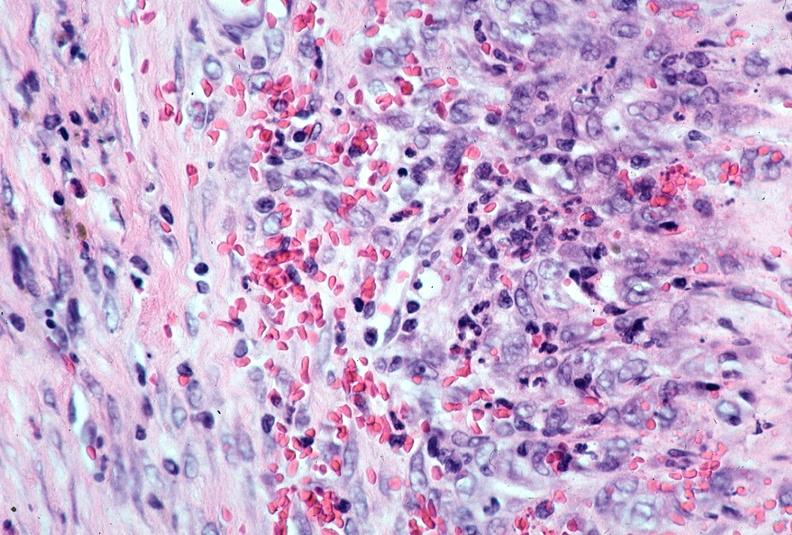what is present?
Answer the question using a single word or phrase. Cardiovascular 